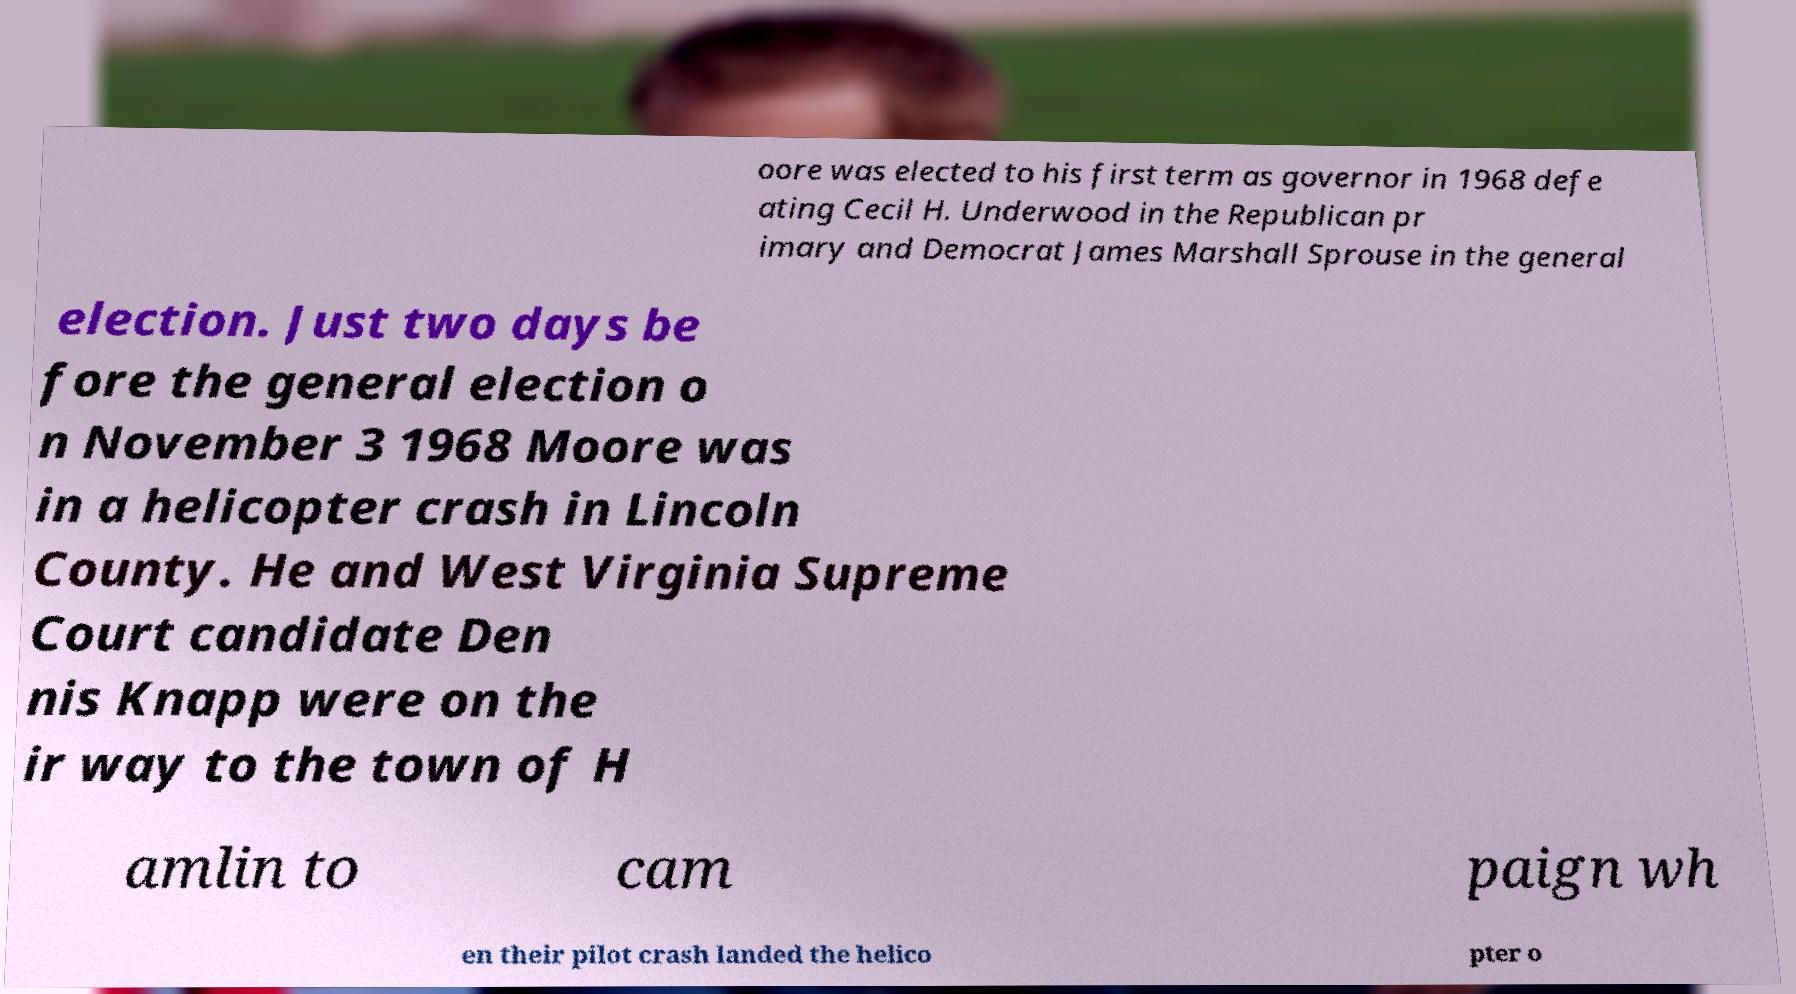For documentation purposes, I need the text within this image transcribed. Could you provide that? oore was elected to his first term as governor in 1968 defe ating Cecil H. Underwood in the Republican pr imary and Democrat James Marshall Sprouse in the general election. Just two days be fore the general election o n November 3 1968 Moore was in a helicopter crash in Lincoln County. He and West Virginia Supreme Court candidate Den nis Knapp were on the ir way to the town of H amlin to cam paign wh en their pilot crash landed the helico pter o 